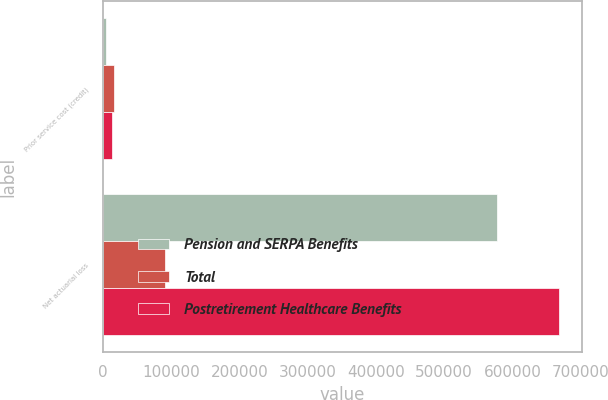Convert chart to OTSL. <chart><loc_0><loc_0><loc_500><loc_500><stacked_bar_chart><ecel><fcel>Prior service cost (credit)<fcel>Net actuarial loss<nl><fcel>Pension and SERPA Benefits<fcel>3489<fcel>577140<nl><fcel>Total<fcel>15921<fcel>91145<nl><fcel>Postretirement Healthcare Benefits<fcel>12432<fcel>668285<nl></chart> 